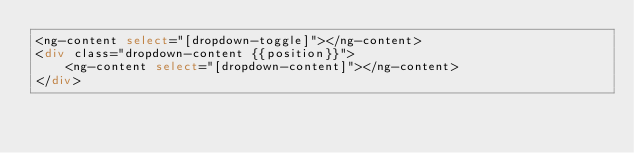<code> <loc_0><loc_0><loc_500><loc_500><_HTML_><ng-content select="[dropdown-toggle]"></ng-content>
<div class="dropdown-content {{position}}">
	<ng-content select="[dropdown-content]"></ng-content>
</div>
</code> 